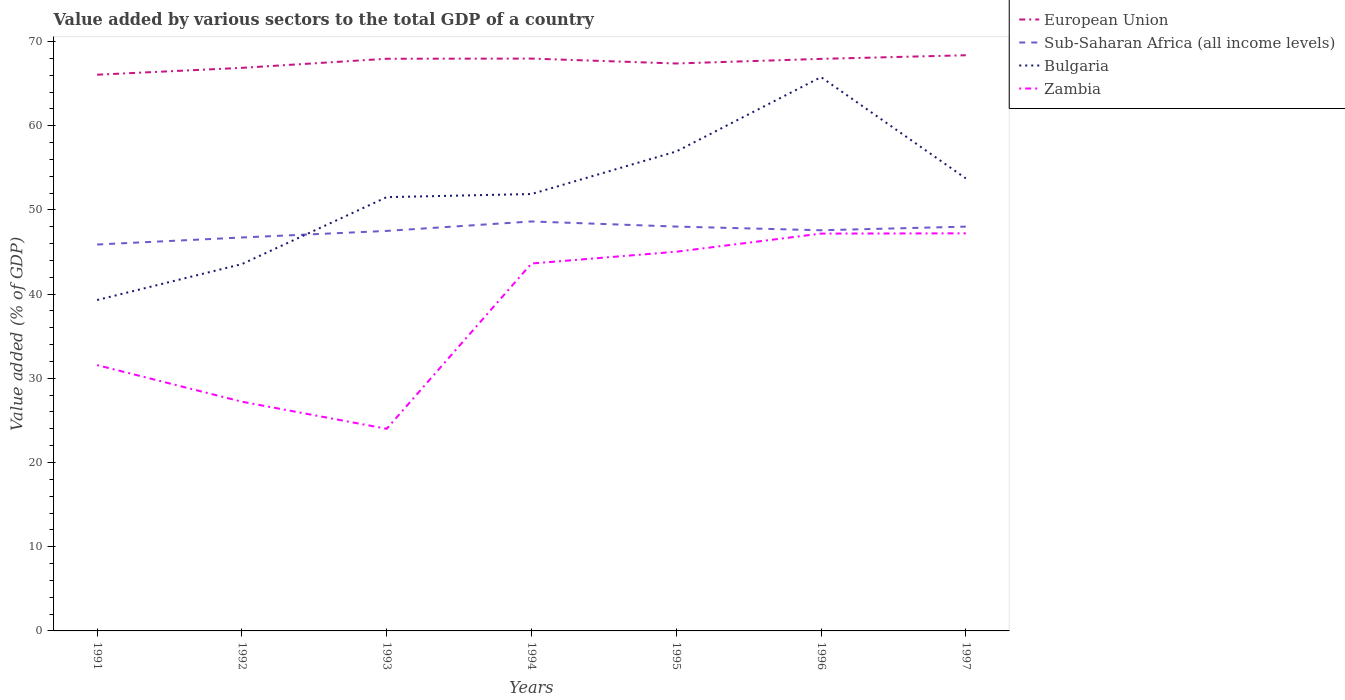Does the line corresponding to European Union intersect with the line corresponding to Sub-Saharan Africa (all income levels)?
Keep it short and to the point. No. Across all years, what is the maximum value added by various sectors to the total GDP in Bulgaria?
Provide a short and direct response. 39.3. What is the total value added by various sectors to the total GDP in European Union in the graph?
Offer a very short reply. -2.31. What is the difference between the highest and the second highest value added by various sectors to the total GDP in Sub-Saharan Africa (all income levels)?
Provide a succinct answer. 2.74. What is the difference between the highest and the lowest value added by various sectors to the total GDP in Sub-Saharan Africa (all income levels)?
Make the answer very short. 5. Is the value added by various sectors to the total GDP in Zambia strictly greater than the value added by various sectors to the total GDP in Bulgaria over the years?
Your answer should be very brief. Yes. How many lines are there?
Provide a succinct answer. 4. Where does the legend appear in the graph?
Your response must be concise. Top right. How many legend labels are there?
Make the answer very short. 4. How are the legend labels stacked?
Provide a succinct answer. Vertical. What is the title of the graph?
Your response must be concise. Value added by various sectors to the total GDP of a country. What is the label or title of the Y-axis?
Your answer should be compact. Value added (% of GDP). What is the Value added (% of GDP) of European Union in 1991?
Make the answer very short. 66.05. What is the Value added (% of GDP) in Sub-Saharan Africa (all income levels) in 1991?
Make the answer very short. 45.89. What is the Value added (% of GDP) of Bulgaria in 1991?
Make the answer very short. 39.3. What is the Value added (% of GDP) in Zambia in 1991?
Your answer should be very brief. 31.57. What is the Value added (% of GDP) in European Union in 1992?
Your answer should be very brief. 66.87. What is the Value added (% of GDP) in Sub-Saharan Africa (all income levels) in 1992?
Offer a terse response. 46.72. What is the Value added (% of GDP) of Bulgaria in 1992?
Ensure brevity in your answer.  43.57. What is the Value added (% of GDP) of Zambia in 1992?
Make the answer very short. 27.22. What is the Value added (% of GDP) of European Union in 1993?
Provide a short and direct response. 67.95. What is the Value added (% of GDP) in Sub-Saharan Africa (all income levels) in 1993?
Your answer should be compact. 47.5. What is the Value added (% of GDP) in Bulgaria in 1993?
Your answer should be compact. 51.52. What is the Value added (% of GDP) of Zambia in 1993?
Provide a succinct answer. 24.01. What is the Value added (% of GDP) in European Union in 1994?
Ensure brevity in your answer.  67.97. What is the Value added (% of GDP) in Sub-Saharan Africa (all income levels) in 1994?
Give a very brief answer. 48.63. What is the Value added (% of GDP) in Bulgaria in 1994?
Your answer should be very brief. 51.88. What is the Value added (% of GDP) of Zambia in 1994?
Keep it short and to the point. 43.63. What is the Value added (% of GDP) in European Union in 1995?
Offer a very short reply. 67.39. What is the Value added (% of GDP) of Sub-Saharan Africa (all income levels) in 1995?
Ensure brevity in your answer.  48.02. What is the Value added (% of GDP) of Bulgaria in 1995?
Offer a terse response. 56.94. What is the Value added (% of GDP) of Zambia in 1995?
Your answer should be compact. 45.03. What is the Value added (% of GDP) of European Union in 1996?
Offer a terse response. 67.94. What is the Value added (% of GDP) of Sub-Saharan Africa (all income levels) in 1996?
Provide a succinct answer. 47.58. What is the Value added (% of GDP) in Bulgaria in 1996?
Your answer should be compact. 65.77. What is the Value added (% of GDP) of Zambia in 1996?
Keep it short and to the point. 47.19. What is the Value added (% of GDP) of European Union in 1997?
Provide a succinct answer. 68.37. What is the Value added (% of GDP) in Sub-Saharan Africa (all income levels) in 1997?
Your answer should be very brief. 48.01. What is the Value added (% of GDP) in Bulgaria in 1997?
Your response must be concise. 53.74. What is the Value added (% of GDP) in Zambia in 1997?
Your response must be concise. 47.22. Across all years, what is the maximum Value added (% of GDP) in European Union?
Give a very brief answer. 68.37. Across all years, what is the maximum Value added (% of GDP) in Sub-Saharan Africa (all income levels)?
Offer a very short reply. 48.63. Across all years, what is the maximum Value added (% of GDP) in Bulgaria?
Make the answer very short. 65.77. Across all years, what is the maximum Value added (% of GDP) of Zambia?
Keep it short and to the point. 47.22. Across all years, what is the minimum Value added (% of GDP) in European Union?
Keep it short and to the point. 66.05. Across all years, what is the minimum Value added (% of GDP) in Sub-Saharan Africa (all income levels)?
Your answer should be compact. 45.89. Across all years, what is the minimum Value added (% of GDP) in Bulgaria?
Your answer should be very brief. 39.3. Across all years, what is the minimum Value added (% of GDP) in Zambia?
Ensure brevity in your answer.  24.01. What is the total Value added (% of GDP) in European Union in the graph?
Provide a short and direct response. 472.53. What is the total Value added (% of GDP) of Sub-Saharan Africa (all income levels) in the graph?
Keep it short and to the point. 332.36. What is the total Value added (% of GDP) in Bulgaria in the graph?
Provide a short and direct response. 362.71. What is the total Value added (% of GDP) in Zambia in the graph?
Keep it short and to the point. 265.86. What is the difference between the Value added (% of GDP) in European Union in 1991 and that in 1992?
Keep it short and to the point. -0.81. What is the difference between the Value added (% of GDP) in Sub-Saharan Africa (all income levels) in 1991 and that in 1992?
Offer a very short reply. -0.83. What is the difference between the Value added (% of GDP) of Bulgaria in 1991 and that in 1992?
Ensure brevity in your answer.  -4.27. What is the difference between the Value added (% of GDP) in Zambia in 1991 and that in 1992?
Provide a succinct answer. 4.35. What is the difference between the Value added (% of GDP) of European Union in 1991 and that in 1993?
Provide a succinct answer. -1.9. What is the difference between the Value added (% of GDP) of Sub-Saharan Africa (all income levels) in 1991 and that in 1993?
Keep it short and to the point. -1.61. What is the difference between the Value added (% of GDP) of Bulgaria in 1991 and that in 1993?
Make the answer very short. -12.22. What is the difference between the Value added (% of GDP) of Zambia in 1991 and that in 1993?
Offer a very short reply. 7.56. What is the difference between the Value added (% of GDP) of European Union in 1991 and that in 1994?
Provide a succinct answer. -1.91. What is the difference between the Value added (% of GDP) in Sub-Saharan Africa (all income levels) in 1991 and that in 1994?
Offer a terse response. -2.74. What is the difference between the Value added (% of GDP) of Bulgaria in 1991 and that in 1994?
Provide a short and direct response. -12.59. What is the difference between the Value added (% of GDP) of Zambia in 1991 and that in 1994?
Your answer should be very brief. -12.07. What is the difference between the Value added (% of GDP) in European Union in 1991 and that in 1995?
Your answer should be compact. -1.33. What is the difference between the Value added (% of GDP) in Sub-Saharan Africa (all income levels) in 1991 and that in 1995?
Offer a terse response. -2.13. What is the difference between the Value added (% of GDP) of Bulgaria in 1991 and that in 1995?
Keep it short and to the point. -17.64. What is the difference between the Value added (% of GDP) in Zambia in 1991 and that in 1995?
Your response must be concise. -13.47. What is the difference between the Value added (% of GDP) in European Union in 1991 and that in 1996?
Provide a succinct answer. -1.88. What is the difference between the Value added (% of GDP) of Sub-Saharan Africa (all income levels) in 1991 and that in 1996?
Offer a very short reply. -1.69. What is the difference between the Value added (% of GDP) of Bulgaria in 1991 and that in 1996?
Offer a very short reply. -26.47. What is the difference between the Value added (% of GDP) of Zambia in 1991 and that in 1996?
Your answer should be very brief. -15.62. What is the difference between the Value added (% of GDP) in European Union in 1991 and that in 1997?
Your answer should be compact. -2.31. What is the difference between the Value added (% of GDP) in Sub-Saharan Africa (all income levels) in 1991 and that in 1997?
Ensure brevity in your answer.  -2.12. What is the difference between the Value added (% of GDP) of Bulgaria in 1991 and that in 1997?
Your response must be concise. -14.44. What is the difference between the Value added (% of GDP) of Zambia in 1991 and that in 1997?
Provide a succinct answer. -15.65. What is the difference between the Value added (% of GDP) of European Union in 1992 and that in 1993?
Keep it short and to the point. -1.08. What is the difference between the Value added (% of GDP) of Sub-Saharan Africa (all income levels) in 1992 and that in 1993?
Keep it short and to the point. -0.78. What is the difference between the Value added (% of GDP) of Bulgaria in 1992 and that in 1993?
Your answer should be compact. -7.95. What is the difference between the Value added (% of GDP) in Zambia in 1992 and that in 1993?
Your answer should be very brief. 3.21. What is the difference between the Value added (% of GDP) in European Union in 1992 and that in 1994?
Your answer should be compact. -1.1. What is the difference between the Value added (% of GDP) in Sub-Saharan Africa (all income levels) in 1992 and that in 1994?
Make the answer very short. -1.9. What is the difference between the Value added (% of GDP) in Bulgaria in 1992 and that in 1994?
Offer a terse response. -8.32. What is the difference between the Value added (% of GDP) in Zambia in 1992 and that in 1994?
Your answer should be compact. -16.41. What is the difference between the Value added (% of GDP) of European Union in 1992 and that in 1995?
Offer a very short reply. -0.52. What is the difference between the Value added (% of GDP) of Sub-Saharan Africa (all income levels) in 1992 and that in 1995?
Offer a terse response. -1.3. What is the difference between the Value added (% of GDP) of Bulgaria in 1992 and that in 1995?
Ensure brevity in your answer.  -13.37. What is the difference between the Value added (% of GDP) of Zambia in 1992 and that in 1995?
Give a very brief answer. -17.81. What is the difference between the Value added (% of GDP) of European Union in 1992 and that in 1996?
Your response must be concise. -1.07. What is the difference between the Value added (% of GDP) in Sub-Saharan Africa (all income levels) in 1992 and that in 1996?
Offer a terse response. -0.86. What is the difference between the Value added (% of GDP) in Bulgaria in 1992 and that in 1996?
Offer a very short reply. -22.2. What is the difference between the Value added (% of GDP) of Zambia in 1992 and that in 1996?
Your answer should be compact. -19.97. What is the difference between the Value added (% of GDP) of European Union in 1992 and that in 1997?
Provide a succinct answer. -1.5. What is the difference between the Value added (% of GDP) in Sub-Saharan Africa (all income levels) in 1992 and that in 1997?
Make the answer very short. -1.29. What is the difference between the Value added (% of GDP) in Bulgaria in 1992 and that in 1997?
Your answer should be compact. -10.17. What is the difference between the Value added (% of GDP) of Zambia in 1992 and that in 1997?
Give a very brief answer. -20. What is the difference between the Value added (% of GDP) in European Union in 1993 and that in 1994?
Offer a terse response. -0.02. What is the difference between the Value added (% of GDP) of Sub-Saharan Africa (all income levels) in 1993 and that in 1994?
Your answer should be very brief. -1.12. What is the difference between the Value added (% of GDP) of Bulgaria in 1993 and that in 1994?
Offer a very short reply. -0.37. What is the difference between the Value added (% of GDP) in Zambia in 1993 and that in 1994?
Give a very brief answer. -19.63. What is the difference between the Value added (% of GDP) in European Union in 1993 and that in 1995?
Provide a short and direct response. 0.56. What is the difference between the Value added (% of GDP) of Sub-Saharan Africa (all income levels) in 1993 and that in 1995?
Provide a short and direct response. -0.52. What is the difference between the Value added (% of GDP) of Bulgaria in 1993 and that in 1995?
Your answer should be very brief. -5.42. What is the difference between the Value added (% of GDP) in Zambia in 1993 and that in 1995?
Offer a terse response. -21.03. What is the difference between the Value added (% of GDP) in European Union in 1993 and that in 1996?
Ensure brevity in your answer.  0.01. What is the difference between the Value added (% of GDP) of Sub-Saharan Africa (all income levels) in 1993 and that in 1996?
Give a very brief answer. -0.08. What is the difference between the Value added (% of GDP) of Bulgaria in 1993 and that in 1996?
Your answer should be very brief. -14.26. What is the difference between the Value added (% of GDP) in Zambia in 1993 and that in 1996?
Your answer should be compact. -23.18. What is the difference between the Value added (% of GDP) of European Union in 1993 and that in 1997?
Your answer should be very brief. -0.42. What is the difference between the Value added (% of GDP) in Sub-Saharan Africa (all income levels) in 1993 and that in 1997?
Keep it short and to the point. -0.51. What is the difference between the Value added (% of GDP) in Bulgaria in 1993 and that in 1997?
Provide a succinct answer. -2.22. What is the difference between the Value added (% of GDP) in Zambia in 1993 and that in 1997?
Provide a succinct answer. -23.21. What is the difference between the Value added (% of GDP) of European Union in 1994 and that in 1995?
Offer a terse response. 0.58. What is the difference between the Value added (% of GDP) of Sub-Saharan Africa (all income levels) in 1994 and that in 1995?
Ensure brevity in your answer.  0.61. What is the difference between the Value added (% of GDP) of Bulgaria in 1994 and that in 1995?
Your answer should be very brief. -5.05. What is the difference between the Value added (% of GDP) of Zambia in 1994 and that in 1995?
Offer a very short reply. -1.4. What is the difference between the Value added (% of GDP) of European Union in 1994 and that in 1996?
Give a very brief answer. 0.03. What is the difference between the Value added (% of GDP) in Sub-Saharan Africa (all income levels) in 1994 and that in 1996?
Make the answer very short. 1.05. What is the difference between the Value added (% of GDP) of Bulgaria in 1994 and that in 1996?
Provide a short and direct response. -13.89. What is the difference between the Value added (% of GDP) of Zambia in 1994 and that in 1996?
Offer a very short reply. -3.55. What is the difference between the Value added (% of GDP) in European Union in 1994 and that in 1997?
Your answer should be very brief. -0.4. What is the difference between the Value added (% of GDP) in Sub-Saharan Africa (all income levels) in 1994 and that in 1997?
Provide a succinct answer. 0.61. What is the difference between the Value added (% of GDP) of Bulgaria in 1994 and that in 1997?
Give a very brief answer. -1.85. What is the difference between the Value added (% of GDP) of Zambia in 1994 and that in 1997?
Offer a very short reply. -3.58. What is the difference between the Value added (% of GDP) in European Union in 1995 and that in 1996?
Keep it short and to the point. -0.55. What is the difference between the Value added (% of GDP) of Sub-Saharan Africa (all income levels) in 1995 and that in 1996?
Provide a succinct answer. 0.44. What is the difference between the Value added (% of GDP) in Bulgaria in 1995 and that in 1996?
Your response must be concise. -8.84. What is the difference between the Value added (% of GDP) of Zambia in 1995 and that in 1996?
Ensure brevity in your answer.  -2.15. What is the difference between the Value added (% of GDP) of European Union in 1995 and that in 1997?
Your answer should be compact. -0.98. What is the difference between the Value added (% of GDP) of Sub-Saharan Africa (all income levels) in 1995 and that in 1997?
Keep it short and to the point. 0.01. What is the difference between the Value added (% of GDP) of Bulgaria in 1995 and that in 1997?
Offer a terse response. 3.2. What is the difference between the Value added (% of GDP) in Zambia in 1995 and that in 1997?
Your answer should be very brief. -2.18. What is the difference between the Value added (% of GDP) in European Union in 1996 and that in 1997?
Your response must be concise. -0.43. What is the difference between the Value added (% of GDP) of Sub-Saharan Africa (all income levels) in 1996 and that in 1997?
Give a very brief answer. -0.43. What is the difference between the Value added (% of GDP) of Bulgaria in 1996 and that in 1997?
Provide a short and direct response. 12.03. What is the difference between the Value added (% of GDP) in Zambia in 1996 and that in 1997?
Your response must be concise. -0.03. What is the difference between the Value added (% of GDP) of European Union in 1991 and the Value added (% of GDP) of Sub-Saharan Africa (all income levels) in 1992?
Give a very brief answer. 19.33. What is the difference between the Value added (% of GDP) of European Union in 1991 and the Value added (% of GDP) of Bulgaria in 1992?
Your response must be concise. 22.49. What is the difference between the Value added (% of GDP) in European Union in 1991 and the Value added (% of GDP) in Zambia in 1992?
Give a very brief answer. 38.83. What is the difference between the Value added (% of GDP) in Sub-Saharan Africa (all income levels) in 1991 and the Value added (% of GDP) in Bulgaria in 1992?
Offer a terse response. 2.32. What is the difference between the Value added (% of GDP) in Sub-Saharan Africa (all income levels) in 1991 and the Value added (% of GDP) in Zambia in 1992?
Make the answer very short. 18.67. What is the difference between the Value added (% of GDP) in Bulgaria in 1991 and the Value added (% of GDP) in Zambia in 1992?
Keep it short and to the point. 12.08. What is the difference between the Value added (% of GDP) in European Union in 1991 and the Value added (% of GDP) in Sub-Saharan Africa (all income levels) in 1993?
Provide a succinct answer. 18.55. What is the difference between the Value added (% of GDP) in European Union in 1991 and the Value added (% of GDP) in Bulgaria in 1993?
Your response must be concise. 14.54. What is the difference between the Value added (% of GDP) of European Union in 1991 and the Value added (% of GDP) of Zambia in 1993?
Give a very brief answer. 42.05. What is the difference between the Value added (% of GDP) in Sub-Saharan Africa (all income levels) in 1991 and the Value added (% of GDP) in Bulgaria in 1993?
Your answer should be compact. -5.63. What is the difference between the Value added (% of GDP) of Sub-Saharan Africa (all income levels) in 1991 and the Value added (% of GDP) of Zambia in 1993?
Your answer should be compact. 21.88. What is the difference between the Value added (% of GDP) of Bulgaria in 1991 and the Value added (% of GDP) of Zambia in 1993?
Your answer should be compact. 15.29. What is the difference between the Value added (% of GDP) of European Union in 1991 and the Value added (% of GDP) of Sub-Saharan Africa (all income levels) in 1994?
Ensure brevity in your answer.  17.43. What is the difference between the Value added (% of GDP) in European Union in 1991 and the Value added (% of GDP) in Bulgaria in 1994?
Offer a terse response. 14.17. What is the difference between the Value added (% of GDP) in European Union in 1991 and the Value added (% of GDP) in Zambia in 1994?
Your answer should be very brief. 22.42. What is the difference between the Value added (% of GDP) in Sub-Saharan Africa (all income levels) in 1991 and the Value added (% of GDP) in Bulgaria in 1994?
Make the answer very short. -6. What is the difference between the Value added (% of GDP) in Sub-Saharan Africa (all income levels) in 1991 and the Value added (% of GDP) in Zambia in 1994?
Ensure brevity in your answer.  2.26. What is the difference between the Value added (% of GDP) of Bulgaria in 1991 and the Value added (% of GDP) of Zambia in 1994?
Your answer should be very brief. -4.34. What is the difference between the Value added (% of GDP) in European Union in 1991 and the Value added (% of GDP) in Sub-Saharan Africa (all income levels) in 1995?
Keep it short and to the point. 18.03. What is the difference between the Value added (% of GDP) in European Union in 1991 and the Value added (% of GDP) in Bulgaria in 1995?
Make the answer very short. 9.12. What is the difference between the Value added (% of GDP) in European Union in 1991 and the Value added (% of GDP) in Zambia in 1995?
Offer a very short reply. 21.02. What is the difference between the Value added (% of GDP) of Sub-Saharan Africa (all income levels) in 1991 and the Value added (% of GDP) of Bulgaria in 1995?
Your response must be concise. -11.05. What is the difference between the Value added (% of GDP) of Sub-Saharan Africa (all income levels) in 1991 and the Value added (% of GDP) of Zambia in 1995?
Give a very brief answer. 0.86. What is the difference between the Value added (% of GDP) of Bulgaria in 1991 and the Value added (% of GDP) of Zambia in 1995?
Offer a very short reply. -5.73. What is the difference between the Value added (% of GDP) of European Union in 1991 and the Value added (% of GDP) of Sub-Saharan Africa (all income levels) in 1996?
Keep it short and to the point. 18.47. What is the difference between the Value added (% of GDP) of European Union in 1991 and the Value added (% of GDP) of Bulgaria in 1996?
Ensure brevity in your answer.  0.28. What is the difference between the Value added (% of GDP) of European Union in 1991 and the Value added (% of GDP) of Zambia in 1996?
Your response must be concise. 18.87. What is the difference between the Value added (% of GDP) in Sub-Saharan Africa (all income levels) in 1991 and the Value added (% of GDP) in Bulgaria in 1996?
Make the answer very short. -19.88. What is the difference between the Value added (% of GDP) in Sub-Saharan Africa (all income levels) in 1991 and the Value added (% of GDP) in Zambia in 1996?
Offer a very short reply. -1.3. What is the difference between the Value added (% of GDP) of Bulgaria in 1991 and the Value added (% of GDP) of Zambia in 1996?
Offer a terse response. -7.89. What is the difference between the Value added (% of GDP) in European Union in 1991 and the Value added (% of GDP) in Sub-Saharan Africa (all income levels) in 1997?
Offer a terse response. 18.04. What is the difference between the Value added (% of GDP) of European Union in 1991 and the Value added (% of GDP) of Bulgaria in 1997?
Your answer should be very brief. 12.32. What is the difference between the Value added (% of GDP) of European Union in 1991 and the Value added (% of GDP) of Zambia in 1997?
Provide a succinct answer. 18.84. What is the difference between the Value added (% of GDP) of Sub-Saharan Africa (all income levels) in 1991 and the Value added (% of GDP) of Bulgaria in 1997?
Your answer should be compact. -7.85. What is the difference between the Value added (% of GDP) in Sub-Saharan Africa (all income levels) in 1991 and the Value added (% of GDP) in Zambia in 1997?
Keep it short and to the point. -1.33. What is the difference between the Value added (% of GDP) in Bulgaria in 1991 and the Value added (% of GDP) in Zambia in 1997?
Keep it short and to the point. -7.92. What is the difference between the Value added (% of GDP) in European Union in 1992 and the Value added (% of GDP) in Sub-Saharan Africa (all income levels) in 1993?
Your answer should be compact. 19.36. What is the difference between the Value added (% of GDP) of European Union in 1992 and the Value added (% of GDP) of Bulgaria in 1993?
Provide a short and direct response. 15.35. What is the difference between the Value added (% of GDP) in European Union in 1992 and the Value added (% of GDP) in Zambia in 1993?
Give a very brief answer. 42.86. What is the difference between the Value added (% of GDP) of Sub-Saharan Africa (all income levels) in 1992 and the Value added (% of GDP) of Bulgaria in 1993?
Provide a succinct answer. -4.79. What is the difference between the Value added (% of GDP) in Sub-Saharan Africa (all income levels) in 1992 and the Value added (% of GDP) in Zambia in 1993?
Your response must be concise. 22.72. What is the difference between the Value added (% of GDP) in Bulgaria in 1992 and the Value added (% of GDP) in Zambia in 1993?
Provide a succinct answer. 19.56. What is the difference between the Value added (% of GDP) of European Union in 1992 and the Value added (% of GDP) of Sub-Saharan Africa (all income levels) in 1994?
Provide a short and direct response. 18.24. What is the difference between the Value added (% of GDP) in European Union in 1992 and the Value added (% of GDP) in Bulgaria in 1994?
Provide a succinct answer. 14.98. What is the difference between the Value added (% of GDP) of European Union in 1992 and the Value added (% of GDP) of Zambia in 1994?
Offer a terse response. 23.24. What is the difference between the Value added (% of GDP) of Sub-Saharan Africa (all income levels) in 1992 and the Value added (% of GDP) of Bulgaria in 1994?
Your response must be concise. -5.16. What is the difference between the Value added (% of GDP) of Sub-Saharan Africa (all income levels) in 1992 and the Value added (% of GDP) of Zambia in 1994?
Provide a succinct answer. 3.09. What is the difference between the Value added (% of GDP) in Bulgaria in 1992 and the Value added (% of GDP) in Zambia in 1994?
Provide a succinct answer. -0.07. What is the difference between the Value added (% of GDP) of European Union in 1992 and the Value added (% of GDP) of Sub-Saharan Africa (all income levels) in 1995?
Offer a terse response. 18.85. What is the difference between the Value added (% of GDP) of European Union in 1992 and the Value added (% of GDP) of Bulgaria in 1995?
Offer a terse response. 9.93. What is the difference between the Value added (% of GDP) in European Union in 1992 and the Value added (% of GDP) in Zambia in 1995?
Keep it short and to the point. 21.84. What is the difference between the Value added (% of GDP) of Sub-Saharan Africa (all income levels) in 1992 and the Value added (% of GDP) of Bulgaria in 1995?
Give a very brief answer. -10.21. What is the difference between the Value added (% of GDP) in Sub-Saharan Africa (all income levels) in 1992 and the Value added (% of GDP) in Zambia in 1995?
Your answer should be very brief. 1.69. What is the difference between the Value added (% of GDP) in Bulgaria in 1992 and the Value added (% of GDP) in Zambia in 1995?
Keep it short and to the point. -1.46. What is the difference between the Value added (% of GDP) of European Union in 1992 and the Value added (% of GDP) of Sub-Saharan Africa (all income levels) in 1996?
Make the answer very short. 19.29. What is the difference between the Value added (% of GDP) in European Union in 1992 and the Value added (% of GDP) in Bulgaria in 1996?
Your answer should be very brief. 1.1. What is the difference between the Value added (% of GDP) of European Union in 1992 and the Value added (% of GDP) of Zambia in 1996?
Offer a very short reply. 19.68. What is the difference between the Value added (% of GDP) in Sub-Saharan Africa (all income levels) in 1992 and the Value added (% of GDP) in Bulgaria in 1996?
Offer a terse response. -19.05. What is the difference between the Value added (% of GDP) in Sub-Saharan Africa (all income levels) in 1992 and the Value added (% of GDP) in Zambia in 1996?
Offer a terse response. -0.46. What is the difference between the Value added (% of GDP) in Bulgaria in 1992 and the Value added (% of GDP) in Zambia in 1996?
Offer a very short reply. -3.62. What is the difference between the Value added (% of GDP) of European Union in 1992 and the Value added (% of GDP) of Sub-Saharan Africa (all income levels) in 1997?
Ensure brevity in your answer.  18.86. What is the difference between the Value added (% of GDP) in European Union in 1992 and the Value added (% of GDP) in Bulgaria in 1997?
Offer a very short reply. 13.13. What is the difference between the Value added (% of GDP) in European Union in 1992 and the Value added (% of GDP) in Zambia in 1997?
Your response must be concise. 19.65. What is the difference between the Value added (% of GDP) of Sub-Saharan Africa (all income levels) in 1992 and the Value added (% of GDP) of Bulgaria in 1997?
Provide a succinct answer. -7.02. What is the difference between the Value added (% of GDP) in Sub-Saharan Africa (all income levels) in 1992 and the Value added (% of GDP) in Zambia in 1997?
Provide a short and direct response. -0.49. What is the difference between the Value added (% of GDP) in Bulgaria in 1992 and the Value added (% of GDP) in Zambia in 1997?
Give a very brief answer. -3.65. What is the difference between the Value added (% of GDP) of European Union in 1993 and the Value added (% of GDP) of Sub-Saharan Africa (all income levels) in 1994?
Offer a terse response. 19.32. What is the difference between the Value added (% of GDP) in European Union in 1993 and the Value added (% of GDP) in Bulgaria in 1994?
Your response must be concise. 16.07. What is the difference between the Value added (% of GDP) of European Union in 1993 and the Value added (% of GDP) of Zambia in 1994?
Make the answer very short. 24.32. What is the difference between the Value added (% of GDP) of Sub-Saharan Africa (all income levels) in 1993 and the Value added (% of GDP) of Bulgaria in 1994?
Give a very brief answer. -4.38. What is the difference between the Value added (% of GDP) of Sub-Saharan Africa (all income levels) in 1993 and the Value added (% of GDP) of Zambia in 1994?
Offer a terse response. 3.87. What is the difference between the Value added (% of GDP) of Bulgaria in 1993 and the Value added (% of GDP) of Zambia in 1994?
Make the answer very short. 7.88. What is the difference between the Value added (% of GDP) of European Union in 1993 and the Value added (% of GDP) of Sub-Saharan Africa (all income levels) in 1995?
Your response must be concise. 19.93. What is the difference between the Value added (% of GDP) of European Union in 1993 and the Value added (% of GDP) of Bulgaria in 1995?
Keep it short and to the point. 11.01. What is the difference between the Value added (% of GDP) in European Union in 1993 and the Value added (% of GDP) in Zambia in 1995?
Your answer should be very brief. 22.92. What is the difference between the Value added (% of GDP) of Sub-Saharan Africa (all income levels) in 1993 and the Value added (% of GDP) of Bulgaria in 1995?
Offer a terse response. -9.43. What is the difference between the Value added (% of GDP) in Sub-Saharan Africa (all income levels) in 1993 and the Value added (% of GDP) in Zambia in 1995?
Your answer should be compact. 2.47. What is the difference between the Value added (% of GDP) of Bulgaria in 1993 and the Value added (% of GDP) of Zambia in 1995?
Make the answer very short. 6.48. What is the difference between the Value added (% of GDP) in European Union in 1993 and the Value added (% of GDP) in Sub-Saharan Africa (all income levels) in 1996?
Provide a short and direct response. 20.37. What is the difference between the Value added (% of GDP) in European Union in 1993 and the Value added (% of GDP) in Bulgaria in 1996?
Your response must be concise. 2.18. What is the difference between the Value added (% of GDP) in European Union in 1993 and the Value added (% of GDP) in Zambia in 1996?
Provide a short and direct response. 20.76. What is the difference between the Value added (% of GDP) of Sub-Saharan Africa (all income levels) in 1993 and the Value added (% of GDP) of Bulgaria in 1996?
Make the answer very short. -18.27. What is the difference between the Value added (% of GDP) in Sub-Saharan Africa (all income levels) in 1993 and the Value added (% of GDP) in Zambia in 1996?
Ensure brevity in your answer.  0.32. What is the difference between the Value added (% of GDP) in Bulgaria in 1993 and the Value added (% of GDP) in Zambia in 1996?
Make the answer very short. 4.33. What is the difference between the Value added (% of GDP) of European Union in 1993 and the Value added (% of GDP) of Sub-Saharan Africa (all income levels) in 1997?
Your response must be concise. 19.94. What is the difference between the Value added (% of GDP) of European Union in 1993 and the Value added (% of GDP) of Bulgaria in 1997?
Provide a short and direct response. 14.21. What is the difference between the Value added (% of GDP) of European Union in 1993 and the Value added (% of GDP) of Zambia in 1997?
Provide a short and direct response. 20.73. What is the difference between the Value added (% of GDP) of Sub-Saharan Africa (all income levels) in 1993 and the Value added (% of GDP) of Bulgaria in 1997?
Offer a terse response. -6.24. What is the difference between the Value added (% of GDP) in Sub-Saharan Africa (all income levels) in 1993 and the Value added (% of GDP) in Zambia in 1997?
Offer a terse response. 0.29. What is the difference between the Value added (% of GDP) in Bulgaria in 1993 and the Value added (% of GDP) in Zambia in 1997?
Provide a short and direct response. 4.3. What is the difference between the Value added (% of GDP) in European Union in 1994 and the Value added (% of GDP) in Sub-Saharan Africa (all income levels) in 1995?
Give a very brief answer. 19.95. What is the difference between the Value added (% of GDP) of European Union in 1994 and the Value added (% of GDP) of Bulgaria in 1995?
Ensure brevity in your answer.  11.03. What is the difference between the Value added (% of GDP) of European Union in 1994 and the Value added (% of GDP) of Zambia in 1995?
Your answer should be compact. 22.94. What is the difference between the Value added (% of GDP) in Sub-Saharan Africa (all income levels) in 1994 and the Value added (% of GDP) in Bulgaria in 1995?
Ensure brevity in your answer.  -8.31. What is the difference between the Value added (% of GDP) of Sub-Saharan Africa (all income levels) in 1994 and the Value added (% of GDP) of Zambia in 1995?
Give a very brief answer. 3.6. What is the difference between the Value added (% of GDP) of Bulgaria in 1994 and the Value added (% of GDP) of Zambia in 1995?
Make the answer very short. 6.85. What is the difference between the Value added (% of GDP) in European Union in 1994 and the Value added (% of GDP) in Sub-Saharan Africa (all income levels) in 1996?
Your response must be concise. 20.39. What is the difference between the Value added (% of GDP) of European Union in 1994 and the Value added (% of GDP) of Bulgaria in 1996?
Provide a short and direct response. 2.2. What is the difference between the Value added (% of GDP) of European Union in 1994 and the Value added (% of GDP) of Zambia in 1996?
Provide a succinct answer. 20.78. What is the difference between the Value added (% of GDP) of Sub-Saharan Africa (all income levels) in 1994 and the Value added (% of GDP) of Bulgaria in 1996?
Make the answer very short. -17.14. What is the difference between the Value added (% of GDP) in Sub-Saharan Africa (all income levels) in 1994 and the Value added (% of GDP) in Zambia in 1996?
Your answer should be very brief. 1.44. What is the difference between the Value added (% of GDP) in Bulgaria in 1994 and the Value added (% of GDP) in Zambia in 1996?
Your response must be concise. 4.7. What is the difference between the Value added (% of GDP) in European Union in 1994 and the Value added (% of GDP) in Sub-Saharan Africa (all income levels) in 1997?
Keep it short and to the point. 19.96. What is the difference between the Value added (% of GDP) in European Union in 1994 and the Value added (% of GDP) in Bulgaria in 1997?
Offer a very short reply. 14.23. What is the difference between the Value added (% of GDP) of European Union in 1994 and the Value added (% of GDP) of Zambia in 1997?
Your response must be concise. 20.75. What is the difference between the Value added (% of GDP) of Sub-Saharan Africa (all income levels) in 1994 and the Value added (% of GDP) of Bulgaria in 1997?
Keep it short and to the point. -5.11. What is the difference between the Value added (% of GDP) of Sub-Saharan Africa (all income levels) in 1994 and the Value added (% of GDP) of Zambia in 1997?
Your answer should be compact. 1.41. What is the difference between the Value added (% of GDP) of Bulgaria in 1994 and the Value added (% of GDP) of Zambia in 1997?
Your response must be concise. 4.67. What is the difference between the Value added (% of GDP) in European Union in 1995 and the Value added (% of GDP) in Sub-Saharan Africa (all income levels) in 1996?
Your answer should be very brief. 19.81. What is the difference between the Value added (% of GDP) of European Union in 1995 and the Value added (% of GDP) of Bulgaria in 1996?
Your answer should be very brief. 1.62. What is the difference between the Value added (% of GDP) in European Union in 1995 and the Value added (% of GDP) in Zambia in 1996?
Ensure brevity in your answer.  20.2. What is the difference between the Value added (% of GDP) in Sub-Saharan Africa (all income levels) in 1995 and the Value added (% of GDP) in Bulgaria in 1996?
Provide a succinct answer. -17.75. What is the difference between the Value added (% of GDP) in Sub-Saharan Africa (all income levels) in 1995 and the Value added (% of GDP) in Zambia in 1996?
Your response must be concise. 0.84. What is the difference between the Value added (% of GDP) in Bulgaria in 1995 and the Value added (% of GDP) in Zambia in 1996?
Give a very brief answer. 9.75. What is the difference between the Value added (% of GDP) of European Union in 1995 and the Value added (% of GDP) of Sub-Saharan Africa (all income levels) in 1997?
Ensure brevity in your answer.  19.37. What is the difference between the Value added (% of GDP) in European Union in 1995 and the Value added (% of GDP) in Bulgaria in 1997?
Your answer should be very brief. 13.65. What is the difference between the Value added (% of GDP) in European Union in 1995 and the Value added (% of GDP) in Zambia in 1997?
Your answer should be very brief. 20.17. What is the difference between the Value added (% of GDP) of Sub-Saharan Africa (all income levels) in 1995 and the Value added (% of GDP) of Bulgaria in 1997?
Your answer should be very brief. -5.72. What is the difference between the Value added (% of GDP) in Sub-Saharan Africa (all income levels) in 1995 and the Value added (% of GDP) in Zambia in 1997?
Provide a short and direct response. 0.8. What is the difference between the Value added (% of GDP) of Bulgaria in 1995 and the Value added (% of GDP) of Zambia in 1997?
Your answer should be compact. 9.72. What is the difference between the Value added (% of GDP) in European Union in 1996 and the Value added (% of GDP) in Sub-Saharan Africa (all income levels) in 1997?
Make the answer very short. 19.92. What is the difference between the Value added (% of GDP) in European Union in 1996 and the Value added (% of GDP) in Bulgaria in 1997?
Keep it short and to the point. 14.2. What is the difference between the Value added (% of GDP) of European Union in 1996 and the Value added (% of GDP) of Zambia in 1997?
Make the answer very short. 20.72. What is the difference between the Value added (% of GDP) in Sub-Saharan Africa (all income levels) in 1996 and the Value added (% of GDP) in Bulgaria in 1997?
Your response must be concise. -6.16. What is the difference between the Value added (% of GDP) in Sub-Saharan Africa (all income levels) in 1996 and the Value added (% of GDP) in Zambia in 1997?
Provide a short and direct response. 0.37. What is the difference between the Value added (% of GDP) of Bulgaria in 1996 and the Value added (% of GDP) of Zambia in 1997?
Make the answer very short. 18.55. What is the average Value added (% of GDP) in European Union per year?
Your response must be concise. 67.5. What is the average Value added (% of GDP) of Sub-Saharan Africa (all income levels) per year?
Give a very brief answer. 47.48. What is the average Value added (% of GDP) in Bulgaria per year?
Your response must be concise. 51.82. What is the average Value added (% of GDP) in Zambia per year?
Provide a succinct answer. 37.98. In the year 1991, what is the difference between the Value added (% of GDP) in European Union and Value added (% of GDP) in Sub-Saharan Africa (all income levels)?
Your response must be concise. 20.17. In the year 1991, what is the difference between the Value added (% of GDP) of European Union and Value added (% of GDP) of Bulgaria?
Ensure brevity in your answer.  26.76. In the year 1991, what is the difference between the Value added (% of GDP) in European Union and Value added (% of GDP) in Zambia?
Offer a very short reply. 34.49. In the year 1991, what is the difference between the Value added (% of GDP) in Sub-Saharan Africa (all income levels) and Value added (% of GDP) in Bulgaria?
Give a very brief answer. 6.59. In the year 1991, what is the difference between the Value added (% of GDP) of Sub-Saharan Africa (all income levels) and Value added (% of GDP) of Zambia?
Ensure brevity in your answer.  14.32. In the year 1991, what is the difference between the Value added (% of GDP) in Bulgaria and Value added (% of GDP) in Zambia?
Your answer should be compact. 7.73. In the year 1992, what is the difference between the Value added (% of GDP) of European Union and Value added (% of GDP) of Sub-Saharan Africa (all income levels)?
Provide a succinct answer. 20.14. In the year 1992, what is the difference between the Value added (% of GDP) in European Union and Value added (% of GDP) in Bulgaria?
Offer a very short reply. 23.3. In the year 1992, what is the difference between the Value added (% of GDP) of European Union and Value added (% of GDP) of Zambia?
Your answer should be very brief. 39.65. In the year 1992, what is the difference between the Value added (% of GDP) in Sub-Saharan Africa (all income levels) and Value added (% of GDP) in Bulgaria?
Offer a terse response. 3.16. In the year 1992, what is the difference between the Value added (% of GDP) in Sub-Saharan Africa (all income levels) and Value added (% of GDP) in Zambia?
Offer a very short reply. 19.5. In the year 1992, what is the difference between the Value added (% of GDP) of Bulgaria and Value added (% of GDP) of Zambia?
Keep it short and to the point. 16.35. In the year 1993, what is the difference between the Value added (% of GDP) of European Union and Value added (% of GDP) of Sub-Saharan Africa (all income levels)?
Keep it short and to the point. 20.45. In the year 1993, what is the difference between the Value added (% of GDP) of European Union and Value added (% of GDP) of Bulgaria?
Make the answer very short. 16.43. In the year 1993, what is the difference between the Value added (% of GDP) of European Union and Value added (% of GDP) of Zambia?
Make the answer very short. 43.94. In the year 1993, what is the difference between the Value added (% of GDP) of Sub-Saharan Africa (all income levels) and Value added (% of GDP) of Bulgaria?
Give a very brief answer. -4.01. In the year 1993, what is the difference between the Value added (% of GDP) in Sub-Saharan Africa (all income levels) and Value added (% of GDP) in Zambia?
Keep it short and to the point. 23.5. In the year 1993, what is the difference between the Value added (% of GDP) of Bulgaria and Value added (% of GDP) of Zambia?
Provide a short and direct response. 27.51. In the year 1994, what is the difference between the Value added (% of GDP) of European Union and Value added (% of GDP) of Sub-Saharan Africa (all income levels)?
Keep it short and to the point. 19.34. In the year 1994, what is the difference between the Value added (% of GDP) of European Union and Value added (% of GDP) of Bulgaria?
Keep it short and to the point. 16.08. In the year 1994, what is the difference between the Value added (% of GDP) in European Union and Value added (% of GDP) in Zambia?
Ensure brevity in your answer.  24.34. In the year 1994, what is the difference between the Value added (% of GDP) of Sub-Saharan Africa (all income levels) and Value added (% of GDP) of Bulgaria?
Make the answer very short. -3.26. In the year 1994, what is the difference between the Value added (% of GDP) of Sub-Saharan Africa (all income levels) and Value added (% of GDP) of Zambia?
Give a very brief answer. 4.99. In the year 1994, what is the difference between the Value added (% of GDP) in Bulgaria and Value added (% of GDP) in Zambia?
Offer a very short reply. 8.25. In the year 1995, what is the difference between the Value added (% of GDP) in European Union and Value added (% of GDP) in Sub-Saharan Africa (all income levels)?
Your answer should be compact. 19.37. In the year 1995, what is the difference between the Value added (% of GDP) in European Union and Value added (% of GDP) in Bulgaria?
Keep it short and to the point. 10.45. In the year 1995, what is the difference between the Value added (% of GDP) in European Union and Value added (% of GDP) in Zambia?
Your response must be concise. 22.36. In the year 1995, what is the difference between the Value added (% of GDP) of Sub-Saharan Africa (all income levels) and Value added (% of GDP) of Bulgaria?
Ensure brevity in your answer.  -8.92. In the year 1995, what is the difference between the Value added (% of GDP) of Sub-Saharan Africa (all income levels) and Value added (% of GDP) of Zambia?
Make the answer very short. 2.99. In the year 1995, what is the difference between the Value added (% of GDP) of Bulgaria and Value added (% of GDP) of Zambia?
Your answer should be very brief. 11.9. In the year 1996, what is the difference between the Value added (% of GDP) in European Union and Value added (% of GDP) in Sub-Saharan Africa (all income levels)?
Your response must be concise. 20.35. In the year 1996, what is the difference between the Value added (% of GDP) in European Union and Value added (% of GDP) in Bulgaria?
Your answer should be very brief. 2.16. In the year 1996, what is the difference between the Value added (% of GDP) of European Union and Value added (% of GDP) of Zambia?
Ensure brevity in your answer.  20.75. In the year 1996, what is the difference between the Value added (% of GDP) in Sub-Saharan Africa (all income levels) and Value added (% of GDP) in Bulgaria?
Give a very brief answer. -18.19. In the year 1996, what is the difference between the Value added (% of GDP) in Sub-Saharan Africa (all income levels) and Value added (% of GDP) in Zambia?
Your response must be concise. 0.4. In the year 1996, what is the difference between the Value added (% of GDP) in Bulgaria and Value added (% of GDP) in Zambia?
Keep it short and to the point. 18.59. In the year 1997, what is the difference between the Value added (% of GDP) of European Union and Value added (% of GDP) of Sub-Saharan Africa (all income levels)?
Give a very brief answer. 20.35. In the year 1997, what is the difference between the Value added (% of GDP) in European Union and Value added (% of GDP) in Bulgaria?
Provide a short and direct response. 14.63. In the year 1997, what is the difference between the Value added (% of GDP) in European Union and Value added (% of GDP) in Zambia?
Ensure brevity in your answer.  21.15. In the year 1997, what is the difference between the Value added (% of GDP) of Sub-Saharan Africa (all income levels) and Value added (% of GDP) of Bulgaria?
Give a very brief answer. -5.73. In the year 1997, what is the difference between the Value added (% of GDP) in Sub-Saharan Africa (all income levels) and Value added (% of GDP) in Zambia?
Make the answer very short. 0.8. In the year 1997, what is the difference between the Value added (% of GDP) in Bulgaria and Value added (% of GDP) in Zambia?
Your response must be concise. 6.52. What is the ratio of the Value added (% of GDP) in European Union in 1991 to that in 1992?
Your answer should be very brief. 0.99. What is the ratio of the Value added (% of GDP) in Sub-Saharan Africa (all income levels) in 1991 to that in 1992?
Give a very brief answer. 0.98. What is the ratio of the Value added (% of GDP) of Bulgaria in 1991 to that in 1992?
Give a very brief answer. 0.9. What is the ratio of the Value added (% of GDP) in Zambia in 1991 to that in 1992?
Keep it short and to the point. 1.16. What is the ratio of the Value added (% of GDP) in European Union in 1991 to that in 1993?
Offer a terse response. 0.97. What is the ratio of the Value added (% of GDP) of Sub-Saharan Africa (all income levels) in 1991 to that in 1993?
Give a very brief answer. 0.97. What is the ratio of the Value added (% of GDP) in Bulgaria in 1991 to that in 1993?
Make the answer very short. 0.76. What is the ratio of the Value added (% of GDP) in Zambia in 1991 to that in 1993?
Provide a succinct answer. 1.31. What is the ratio of the Value added (% of GDP) in European Union in 1991 to that in 1994?
Make the answer very short. 0.97. What is the ratio of the Value added (% of GDP) in Sub-Saharan Africa (all income levels) in 1991 to that in 1994?
Give a very brief answer. 0.94. What is the ratio of the Value added (% of GDP) of Bulgaria in 1991 to that in 1994?
Provide a short and direct response. 0.76. What is the ratio of the Value added (% of GDP) in Zambia in 1991 to that in 1994?
Make the answer very short. 0.72. What is the ratio of the Value added (% of GDP) in European Union in 1991 to that in 1995?
Keep it short and to the point. 0.98. What is the ratio of the Value added (% of GDP) in Sub-Saharan Africa (all income levels) in 1991 to that in 1995?
Provide a succinct answer. 0.96. What is the ratio of the Value added (% of GDP) of Bulgaria in 1991 to that in 1995?
Keep it short and to the point. 0.69. What is the ratio of the Value added (% of GDP) in Zambia in 1991 to that in 1995?
Your answer should be very brief. 0.7. What is the ratio of the Value added (% of GDP) in European Union in 1991 to that in 1996?
Offer a terse response. 0.97. What is the ratio of the Value added (% of GDP) in Sub-Saharan Africa (all income levels) in 1991 to that in 1996?
Offer a terse response. 0.96. What is the ratio of the Value added (% of GDP) of Bulgaria in 1991 to that in 1996?
Offer a very short reply. 0.6. What is the ratio of the Value added (% of GDP) in Zambia in 1991 to that in 1996?
Ensure brevity in your answer.  0.67. What is the ratio of the Value added (% of GDP) of European Union in 1991 to that in 1997?
Make the answer very short. 0.97. What is the ratio of the Value added (% of GDP) of Sub-Saharan Africa (all income levels) in 1991 to that in 1997?
Keep it short and to the point. 0.96. What is the ratio of the Value added (% of GDP) in Bulgaria in 1991 to that in 1997?
Your answer should be very brief. 0.73. What is the ratio of the Value added (% of GDP) of Zambia in 1991 to that in 1997?
Give a very brief answer. 0.67. What is the ratio of the Value added (% of GDP) of European Union in 1992 to that in 1993?
Ensure brevity in your answer.  0.98. What is the ratio of the Value added (% of GDP) of Sub-Saharan Africa (all income levels) in 1992 to that in 1993?
Make the answer very short. 0.98. What is the ratio of the Value added (% of GDP) in Bulgaria in 1992 to that in 1993?
Ensure brevity in your answer.  0.85. What is the ratio of the Value added (% of GDP) of Zambia in 1992 to that in 1993?
Your answer should be compact. 1.13. What is the ratio of the Value added (% of GDP) in European Union in 1992 to that in 1994?
Offer a terse response. 0.98. What is the ratio of the Value added (% of GDP) of Sub-Saharan Africa (all income levels) in 1992 to that in 1994?
Keep it short and to the point. 0.96. What is the ratio of the Value added (% of GDP) in Bulgaria in 1992 to that in 1994?
Ensure brevity in your answer.  0.84. What is the ratio of the Value added (% of GDP) of Zambia in 1992 to that in 1994?
Offer a very short reply. 0.62. What is the ratio of the Value added (% of GDP) in Sub-Saharan Africa (all income levels) in 1992 to that in 1995?
Provide a succinct answer. 0.97. What is the ratio of the Value added (% of GDP) in Bulgaria in 1992 to that in 1995?
Offer a very short reply. 0.77. What is the ratio of the Value added (% of GDP) in Zambia in 1992 to that in 1995?
Ensure brevity in your answer.  0.6. What is the ratio of the Value added (% of GDP) of European Union in 1992 to that in 1996?
Make the answer very short. 0.98. What is the ratio of the Value added (% of GDP) of Sub-Saharan Africa (all income levels) in 1992 to that in 1996?
Provide a short and direct response. 0.98. What is the ratio of the Value added (% of GDP) of Bulgaria in 1992 to that in 1996?
Provide a succinct answer. 0.66. What is the ratio of the Value added (% of GDP) in Zambia in 1992 to that in 1996?
Provide a succinct answer. 0.58. What is the ratio of the Value added (% of GDP) in European Union in 1992 to that in 1997?
Ensure brevity in your answer.  0.98. What is the ratio of the Value added (% of GDP) in Sub-Saharan Africa (all income levels) in 1992 to that in 1997?
Provide a succinct answer. 0.97. What is the ratio of the Value added (% of GDP) in Bulgaria in 1992 to that in 1997?
Keep it short and to the point. 0.81. What is the ratio of the Value added (% of GDP) of Zambia in 1992 to that in 1997?
Give a very brief answer. 0.58. What is the ratio of the Value added (% of GDP) in Sub-Saharan Africa (all income levels) in 1993 to that in 1994?
Your answer should be very brief. 0.98. What is the ratio of the Value added (% of GDP) of Zambia in 1993 to that in 1994?
Your answer should be compact. 0.55. What is the ratio of the Value added (% of GDP) in European Union in 1993 to that in 1995?
Give a very brief answer. 1.01. What is the ratio of the Value added (% of GDP) of Sub-Saharan Africa (all income levels) in 1993 to that in 1995?
Provide a succinct answer. 0.99. What is the ratio of the Value added (% of GDP) of Bulgaria in 1993 to that in 1995?
Provide a succinct answer. 0.9. What is the ratio of the Value added (% of GDP) in Zambia in 1993 to that in 1995?
Offer a terse response. 0.53. What is the ratio of the Value added (% of GDP) in European Union in 1993 to that in 1996?
Provide a short and direct response. 1. What is the ratio of the Value added (% of GDP) of Bulgaria in 1993 to that in 1996?
Your response must be concise. 0.78. What is the ratio of the Value added (% of GDP) in Zambia in 1993 to that in 1996?
Ensure brevity in your answer.  0.51. What is the ratio of the Value added (% of GDP) of Sub-Saharan Africa (all income levels) in 1993 to that in 1997?
Your answer should be very brief. 0.99. What is the ratio of the Value added (% of GDP) in Bulgaria in 1993 to that in 1997?
Your answer should be very brief. 0.96. What is the ratio of the Value added (% of GDP) in Zambia in 1993 to that in 1997?
Provide a succinct answer. 0.51. What is the ratio of the Value added (% of GDP) of European Union in 1994 to that in 1995?
Offer a very short reply. 1.01. What is the ratio of the Value added (% of GDP) of Sub-Saharan Africa (all income levels) in 1994 to that in 1995?
Your answer should be compact. 1.01. What is the ratio of the Value added (% of GDP) of Bulgaria in 1994 to that in 1995?
Give a very brief answer. 0.91. What is the ratio of the Value added (% of GDP) in Zambia in 1994 to that in 1995?
Provide a succinct answer. 0.97. What is the ratio of the Value added (% of GDP) of Sub-Saharan Africa (all income levels) in 1994 to that in 1996?
Ensure brevity in your answer.  1.02. What is the ratio of the Value added (% of GDP) of Bulgaria in 1994 to that in 1996?
Offer a very short reply. 0.79. What is the ratio of the Value added (% of GDP) of Zambia in 1994 to that in 1996?
Give a very brief answer. 0.92. What is the ratio of the Value added (% of GDP) in European Union in 1994 to that in 1997?
Provide a succinct answer. 0.99. What is the ratio of the Value added (% of GDP) in Sub-Saharan Africa (all income levels) in 1994 to that in 1997?
Ensure brevity in your answer.  1.01. What is the ratio of the Value added (% of GDP) in Bulgaria in 1994 to that in 1997?
Your answer should be very brief. 0.97. What is the ratio of the Value added (% of GDP) of Zambia in 1994 to that in 1997?
Ensure brevity in your answer.  0.92. What is the ratio of the Value added (% of GDP) of Sub-Saharan Africa (all income levels) in 1995 to that in 1996?
Keep it short and to the point. 1.01. What is the ratio of the Value added (% of GDP) of Bulgaria in 1995 to that in 1996?
Give a very brief answer. 0.87. What is the ratio of the Value added (% of GDP) in Zambia in 1995 to that in 1996?
Ensure brevity in your answer.  0.95. What is the ratio of the Value added (% of GDP) of European Union in 1995 to that in 1997?
Keep it short and to the point. 0.99. What is the ratio of the Value added (% of GDP) of Sub-Saharan Africa (all income levels) in 1995 to that in 1997?
Offer a terse response. 1. What is the ratio of the Value added (% of GDP) in Bulgaria in 1995 to that in 1997?
Ensure brevity in your answer.  1.06. What is the ratio of the Value added (% of GDP) in Zambia in 1995 to that in 1997?
Your answer should be compact. 0.95. What is the ratio of the Value added (% of GDP) in Sub-Saharan Africa (all income levels) in 1996 to that in 1997?
Provide a short and direct response. 0.99. What is the ratio of the Value added (% of GDP) in Bulgaria in 1996 to that in 1997?
Give a very brief answer. 1.22. What is the difference between the highest and the second highest Value added (% of GDP) in European Union?
Your response must be concise. 0.4. What is the difference between the highest and the second highest Value added (% of GDP) in Sub-Saharan Africa (all income levels)?
Offer a terse response. 0.61. What is the difference between the highest and the second highest Value added (% of GDP) of Bulgaria?
Your response must be concise. 8.84. What is the difference between the highest and the second highest Value added (% of GDP) in Zambia?
Give a very brief answer. 0.03. What is the difference between the highest and the lowest Value added (% of GDP) of European Union?
Make the answer very short. 2.31. What is the difference between the highest and the lowest Value added (% of GDP) of Sub-Saharan Africa (all income levels)?
Your answer should be compact. 2.74. What is the difference between the highest and the lowest Value added (% of GDP) in Bulgaria?
Give a very brief answer. 26.47. What is the difference between the highest and the lowest Value added (% of GDP) in Zambia?
Provide a short and direct response. 23.21. 